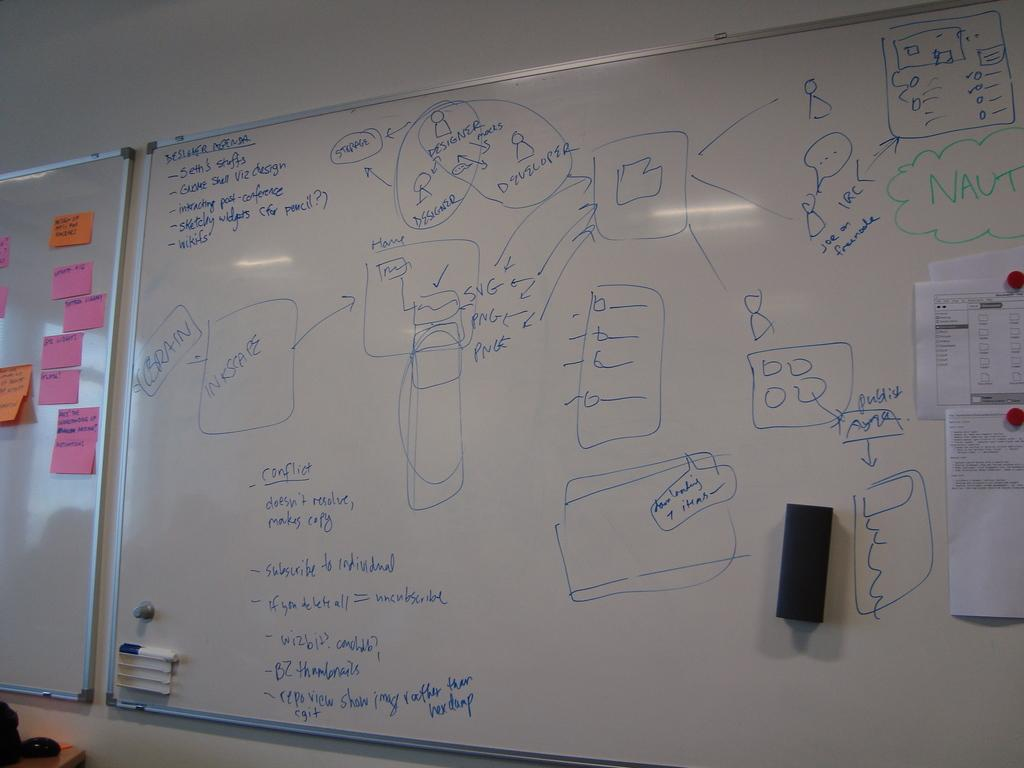<image>
Offer a succinct explanation of the picture presented. White board with a complicated flow chart relating to conflict and design and developers 